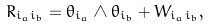<formula> <loc_0><loc_0><loc_500><loc_500>R _ { i _ { a } i _ { b } } = \theta _ { i _ { a } } \wedge \theta _ { i _ { b } } + W _ { i _ { a } i _ { b } } ,</formula> 